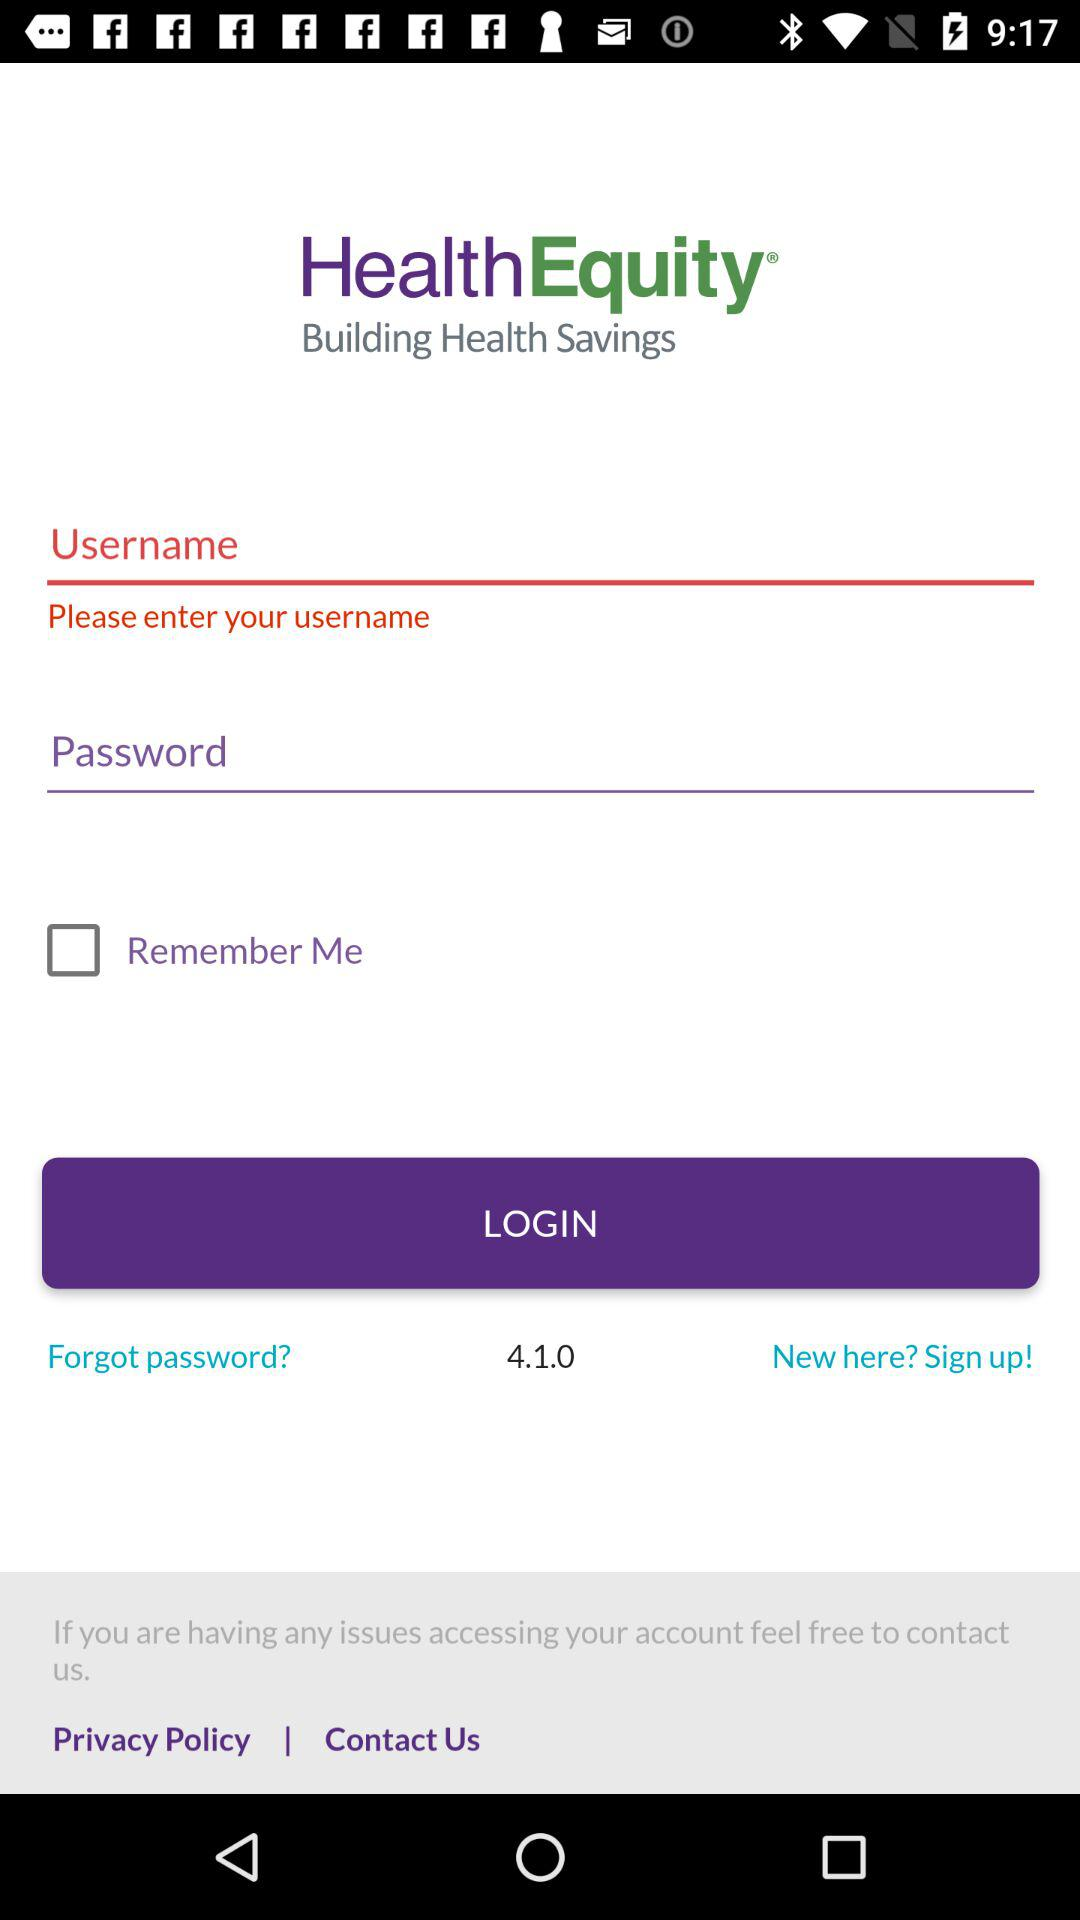What is the name of the application? The name of the application is "HealthEquity". 